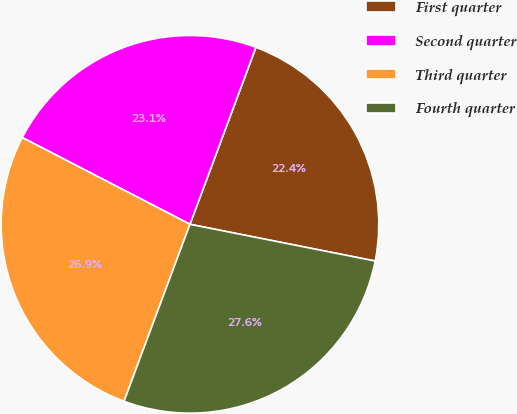<chart> <loc_0><loc_0><loc_500><loc_500><pie_chart><fcel>First quarter<fcel>Second quarter<fcel>Third quarter<fcel>Fourth quarter<nl><fcel>22.44%<fcel>23.08%<fcel>26.92%<fcel>27.56%<nl></chart> 